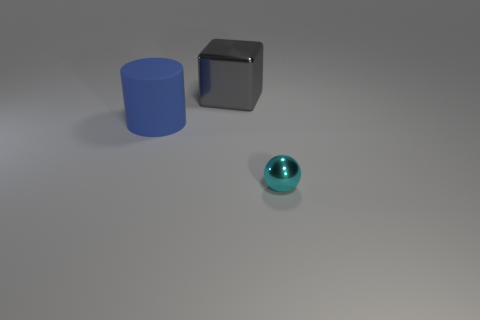Are there any blue objects in front of the small metal object?
Your response must be concise. No. Are there any other things that have the same size as the shiny ball?
Provide a succinct answer. No. Is the shape of the gray metal object the same as the cyan metal object?
Your answer should be compact. No. What is the size of the shiny object that is to the right of the metallic object behind the small cyan metal object?
Provide a short and direct response. Small. What is the size of the gray shiny cube?
Provide a succinct answer. Large. Do the blue rubber cylinder and the cyan shiny object have the same size?
Provide a succinct answer. No. What is the color of the thing that is both to the right of the blue cylinder and to the left of the small thing?
Offer a terse response. Gray. How many things have the same material as the small ball?
Keep it short and to the point. 1. What number of big yellow metal cubes are there?
Your answer should be very brief. 0. Does the gray metallic block have the same size as the shiny object that is on the right side of the big gray cube?
Make the answer very short. No. 